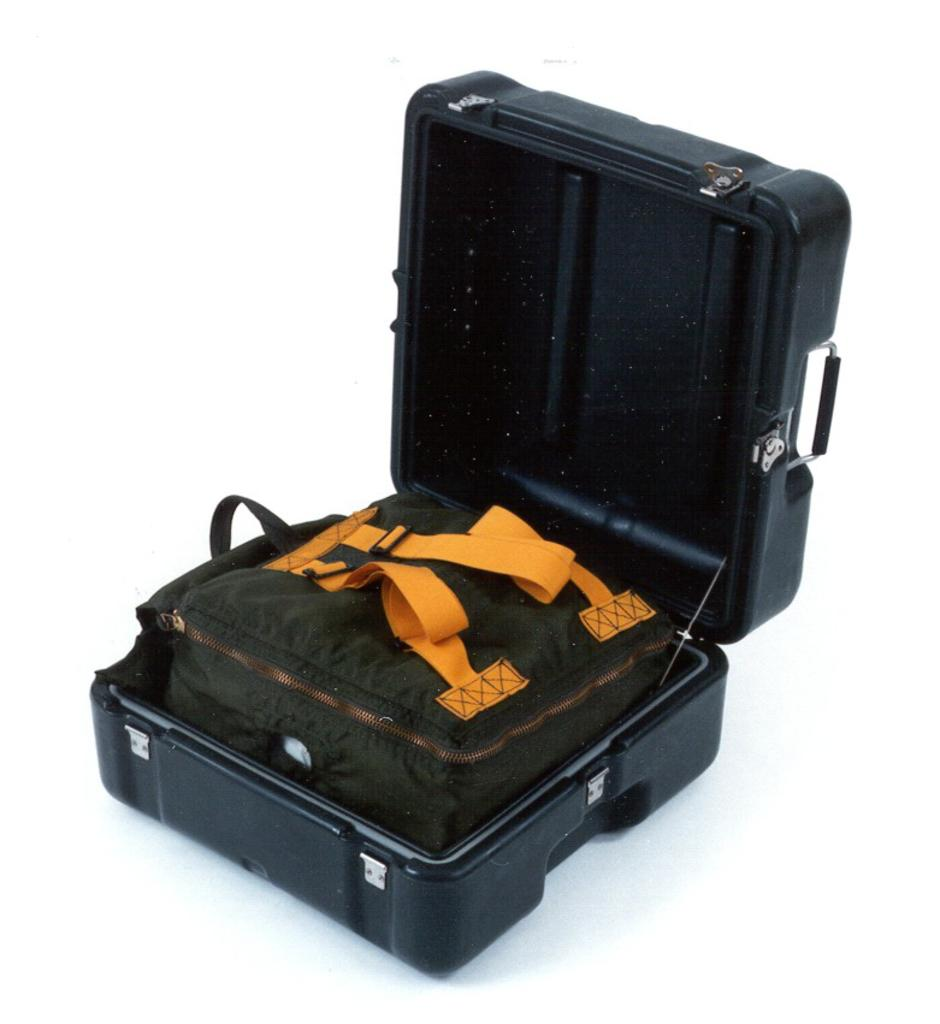What is the color of the container in the image? The container in the image is black. What other object can be seen in the image? There is a green bag in the image. What detail can be observed about the green bag? The green bag has yellow handles. Is the image taken during a hot night? The provided facts do not mention the temperature or time of day, so we cannot determine if the image was taken during a hot night. Additionally, there is no information about the weather or time of day in the image. 